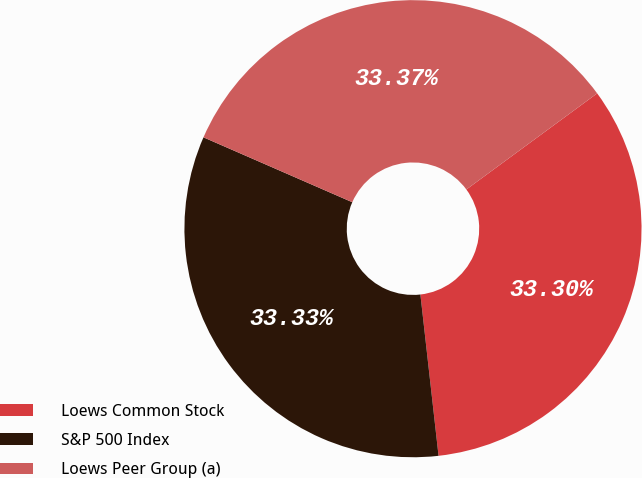<chart> <loc_0><loc_0><loc_500><loc_500><pie_chart><fcel>Loews Common Stock<fcel>S&P 500 Index<fcel>Loews Peer Group (a)<nl><fcel>33.3%<fcel>33.33%<fcel>33.37%<nl></chart> 